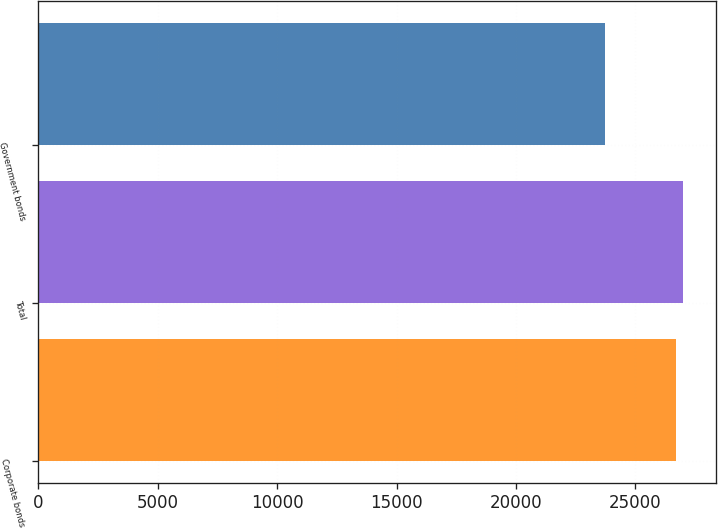Convert chart. <chart><loc_0><loc_0><loc_500><loc_500><bar_chart><fcel>Corporate bonds<fcel>Total<fcel>Government bonds<nl><fcel>26704<fcel>27002.7<fcel>23717<nl></chart> 